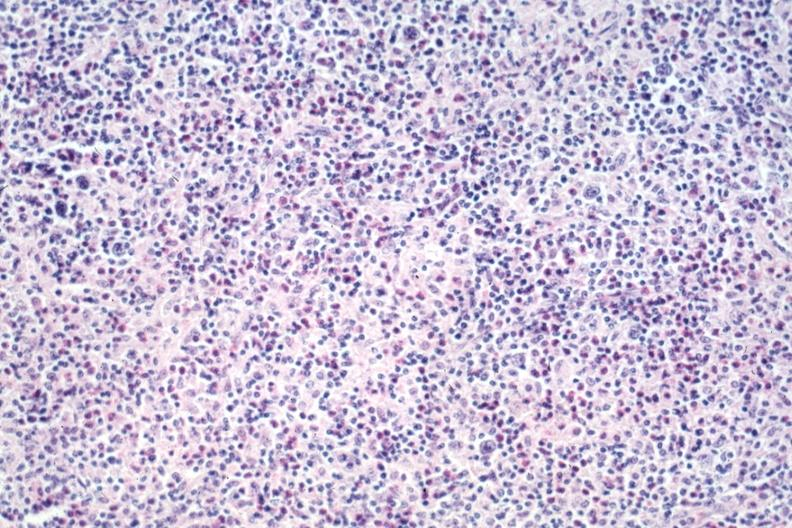what is present?
Answer the question using a single word or phrase. Hodgkins disease 